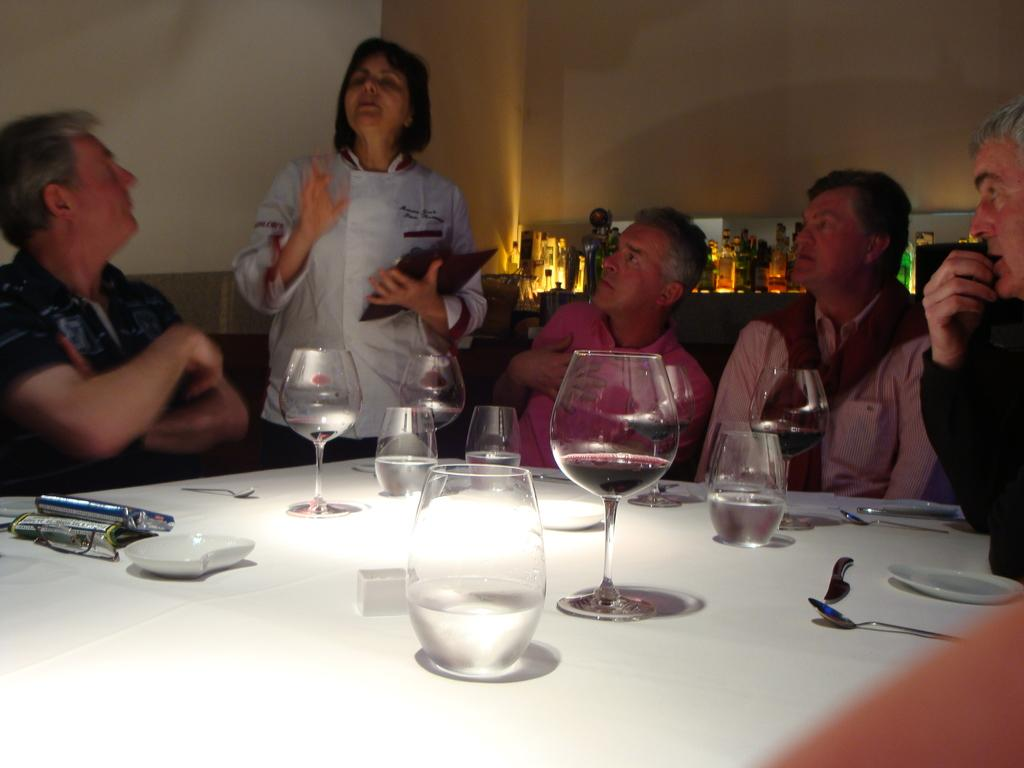How many people are in the image? There are four men in the image. What are the men doing in the image? The men are sitting around a table. What is the woman in the image doing? The woman is taking an order. What items can be seen on the table in the image? There are glasses of water, plates, forks, and spoons on the table. What type of coat is the woman wearing in the image? There is no coat visible in the image; the woman is not wearing one. What advice is the woman giving to the men in the image? The woman is not giving any advice in the image; she is taking an order. 